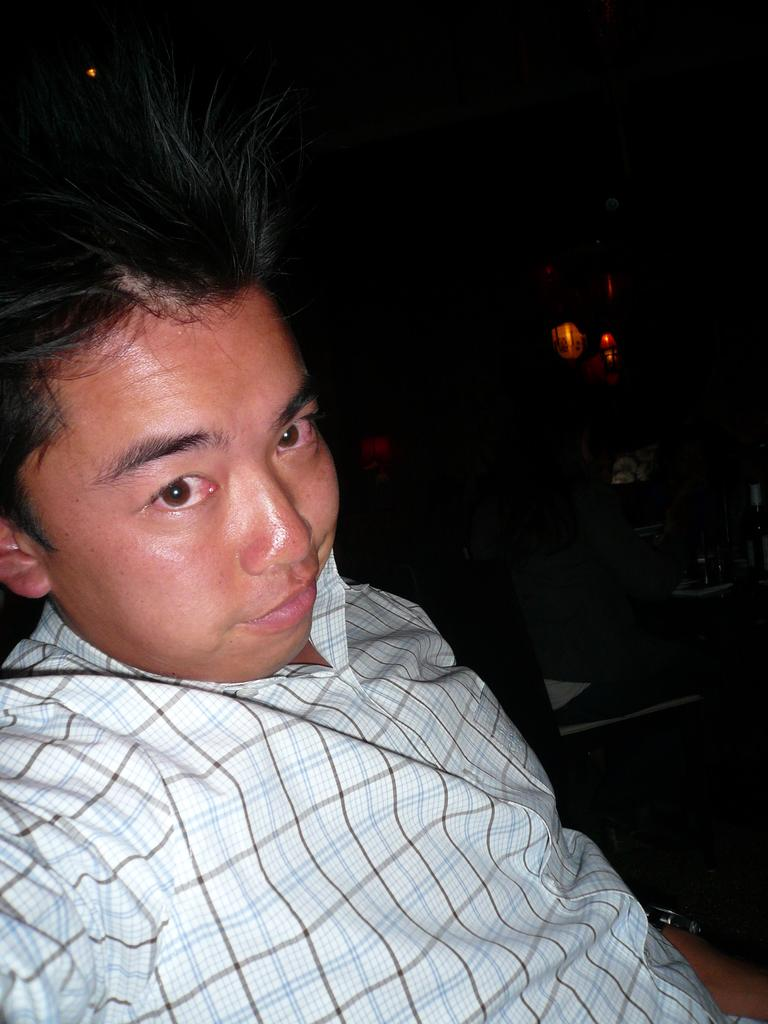Who is the main subject in the image? There is a man in the image. What is the man wearing? The man is wearing a white and black checkered shirt. Can you describe the person sitting in the background of the image? There is a person sitting on a chair in the background of the image. What can be seen in the dark background of the image? There are lights visible in the dark background of the image. What type of silverware is the maid using in the image? There is no maid or silverware present in the image. What statement does the man make in the image? The image does not contain any dialogue or text, so it is not possible to determine what statement the man might make. 